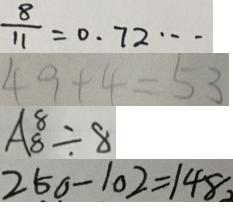Convert formula to latex. <formula><loc_0><loc_0><loc_500><loc_500>\frac { 8 } { 1 1 } = 0 . 7 2 \cdots 
 4 9 + 4 = 5 3 
 A _ { 8 } ^ { 8 } \div 8 
 2 5 0 - 1 0 2 = 1 4 8</formula> 